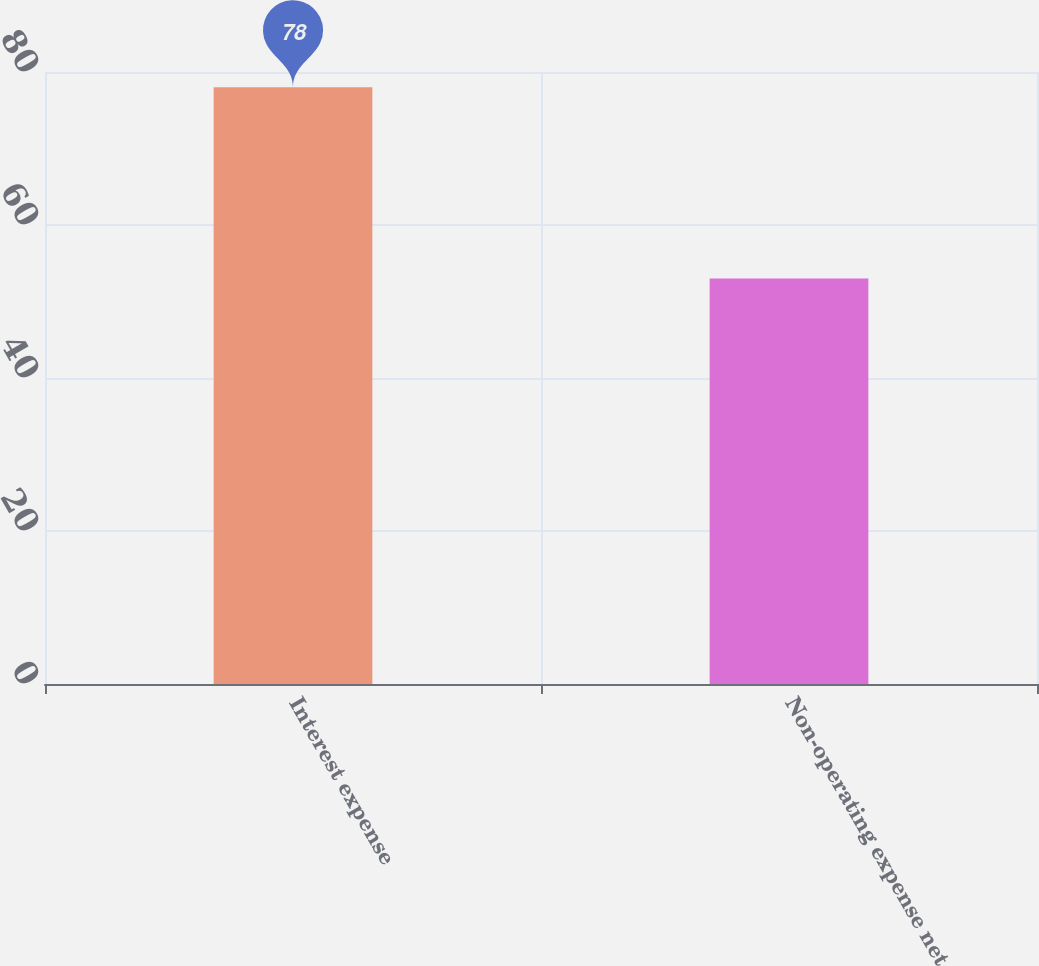Convert chart to OTSL. <chart><loc_0><loc_0><loc_500><loc_500><bar_chart><fcel>Interest expense<fcel>Non-operating expense net<nl><fcel>78<fcel>53<nl></chart> 